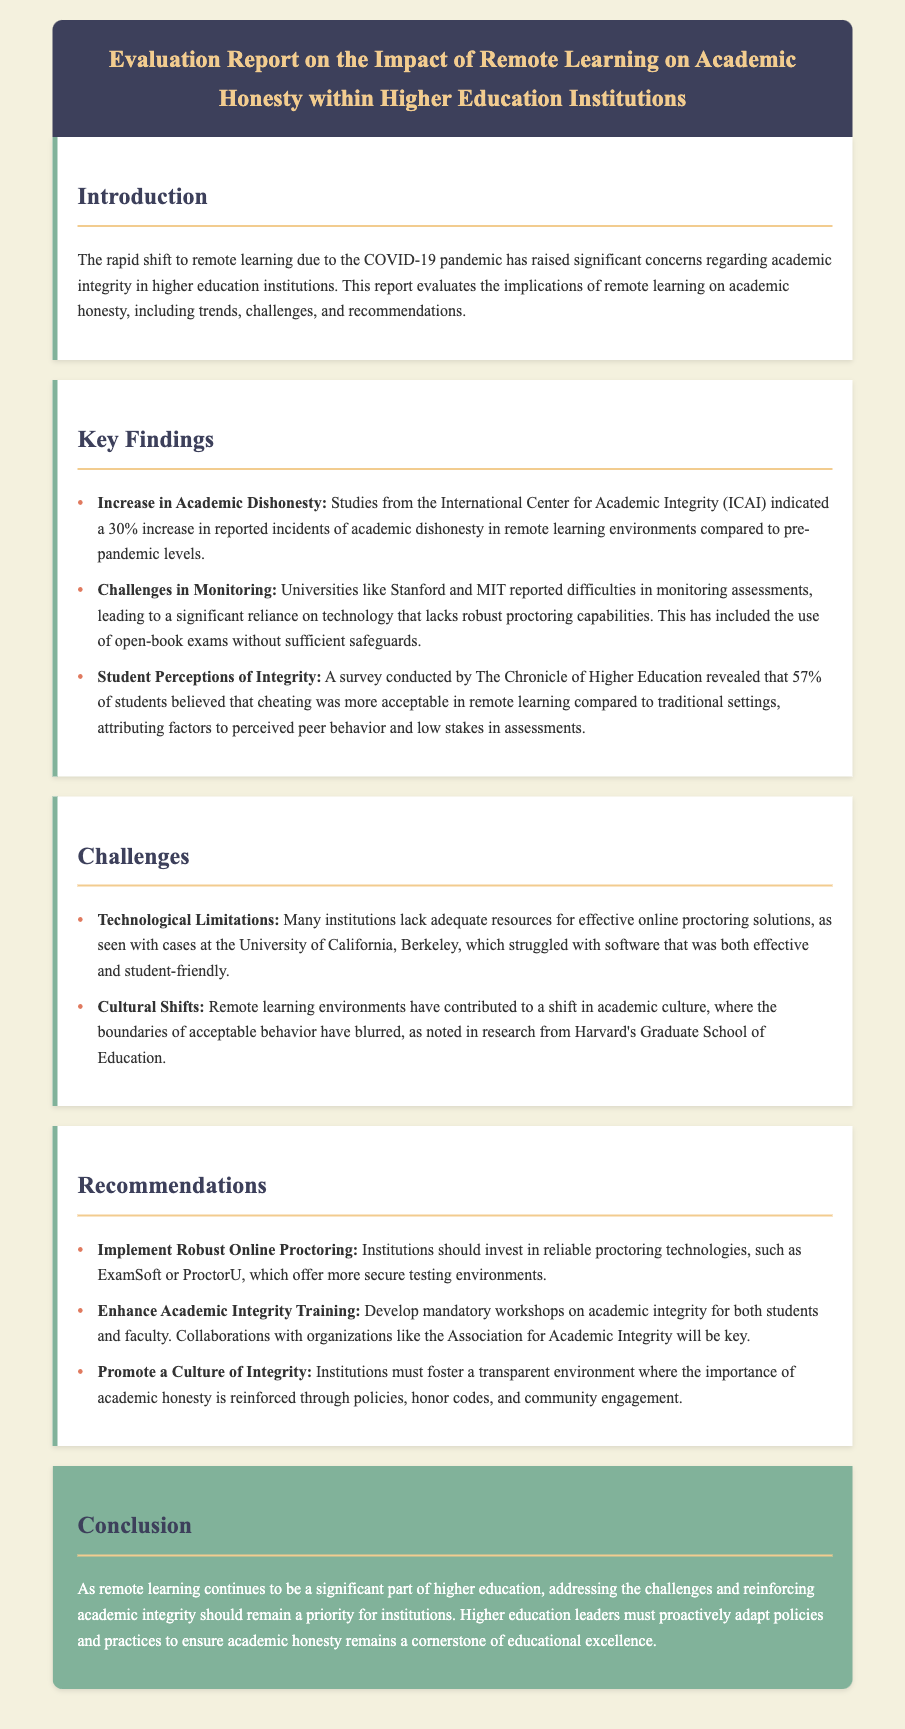What is the title of the report? The title of the report is explicitly provided at the top of the document under the header section.
Answer: Evaluation Report on the Impact of Remote Learning on Academic Honesty within Higher Education Institutions What percentage increase in academic dishonesty was reported? The document states that there was a 30% increase in reported incidents of academic dishonesty during remote learning.
Answer: 30% Which organization conducted a relevant survey on student perceptions of integrity? The document mentions that the survey was conducted by The Chronicle of Higher Education regarding student perceptions of academic integrity.
Answer: The Chronicle of Higher Education What is one major challenge faced by universities in remote learning? The document lists several challenges, one of which is related to monitoring assessments effectively in remote learning environments.
Answer: Challenges in Monitoring What is a recommended action for institutions to enhance academic integrity? The report recommends developing mandatory workshops on academic integrity for both students and faculty as a key action.
Answer: Enhance Academic Integrity Training What institution struggled with effective online proctoring solutions? The document notes that the University of California, Berkeley struggled with effective online proctoring solutions for remote assessments.
Answer: University of California, Berkeley What is emphasized as essential for higher education leaders in the conclusion? The conclusion emphasizes that addressing challenges and reinforcing academic integrity should remain a priority for institutions.
Answer: Priority for Institutions What is the primary concern raised due to the shift to remote learning? The document's introduction states that significant concerns have been raised regarding academic integrity in higher education institutions due to remote learning.
Answer: Academic Integrity 